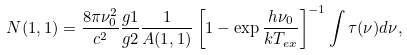Convert formula to latex. <formula><loc_0><loc_0><loc_500><loc_500>N ( 1 , 1 ) = \frac { 8 \pi \nu _ { 0 } ^ { 2 } } { c ^ { 2 } } \frac { g 1 } { g 2 } \frac { 1 } { A ( 1 , 1 ) } \left [ 1 - \exp { \frac { h \nu _ { 0 } } { k T _ { e x } } } \right ] ^ { - 1 } \int { \tau ( \nu ) d \nu } ,</formula> 